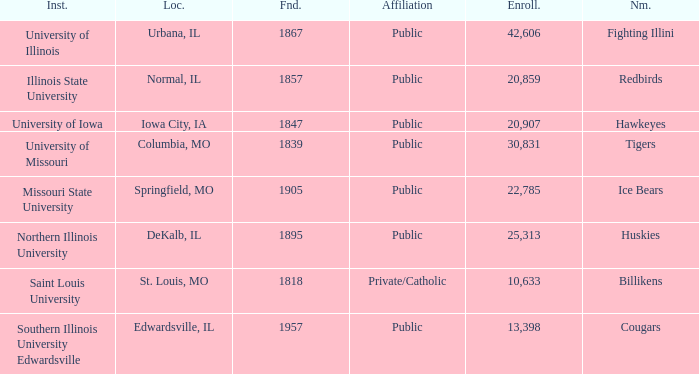Parse the full table. {'header': ['Inst.', 'Loc.', 'Fnd.', 'Affiliation', 'Enroll.', 'Nm.'], 'rows': [['University of Illinois', 'Urbana, IL', '1867', 'Public', '42,606', 'Fighting Illini'], ['Illinois State University', 'Normal, IL', '1857', 'Public', '20,859', 'Redbirds'], ['University of Iowa', 'Iowa City, IA', '1847', 'Public', '20,907', 'Hawkeyes'], ['University of Missouri', 'Columbia, MO', '1839', 'Public', '30,831', 'Tigers'], ['Missouri State University', 'Springfield, MO', '1905', 'Public', '22,785', 'Ice Bears'], ['Northern Illinois University', 'DeKalb, IL', '1895', 'Public', '25,313', 'Huskies'], ['Saint Louis University', 'St. Louis, MO', '1818', 'Private/Catholic', '10,633', 'Billikens'], ['Southern Illinois University Edwardsville', 'Edwardsville, IL', '1957', 'Public', '13,398', 'Cougars']]} What is Southern Illinois University Edwardsville's affiliation? Public. 